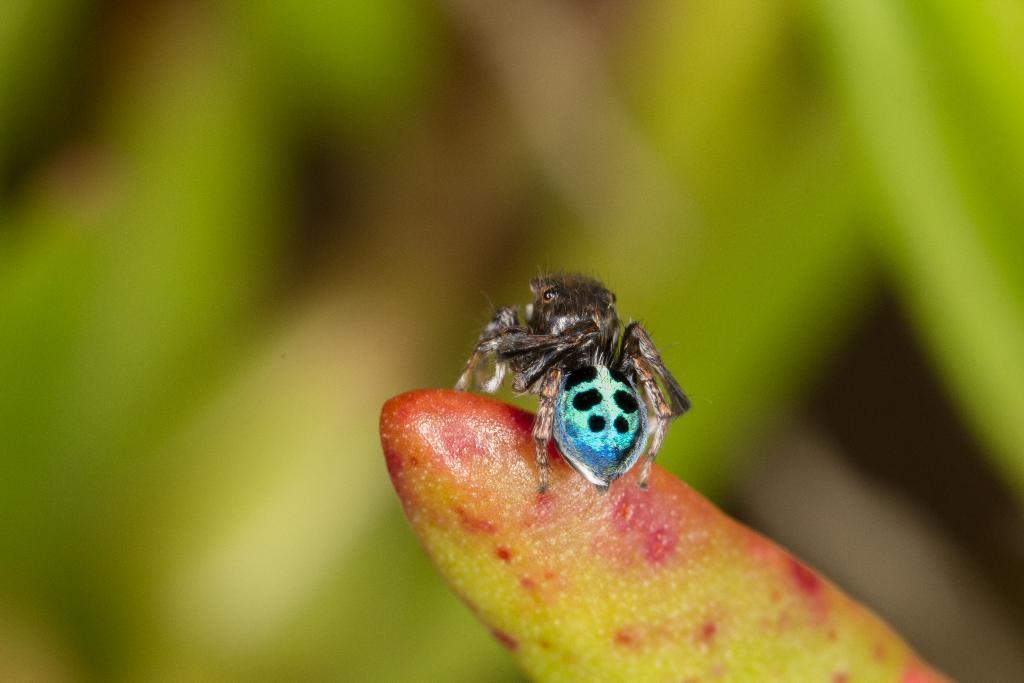What type of creature is present in the image? There is an insect in the image. Where is the insect located? The insect is on a flower bush. What can be observed about the background of the image? The background of the image appears green and blurred. What type of vest is the insect wearing in the image? There is no vest present on the insect in the image. Is there any eggnog visible in the image? There is no eggnog present in the image. 